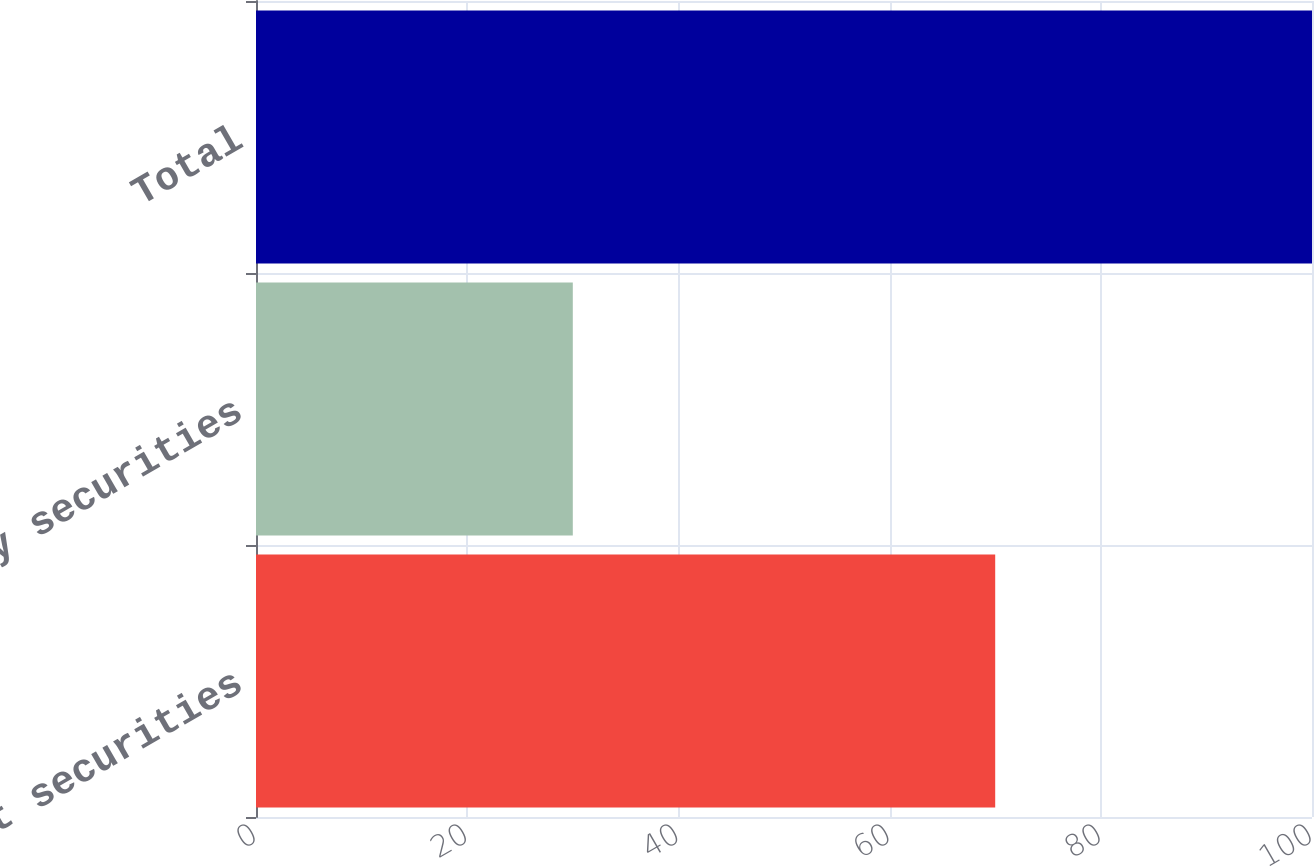Convert chart to OTSL. <chart><loc_0><loc_0><loc_500><loc_500><bar_chart><fcel>Debt securities<fcel>Equity securities<fcel>Total<nl><fcel>70<fcel>30<fcel>100<nl></chart> 